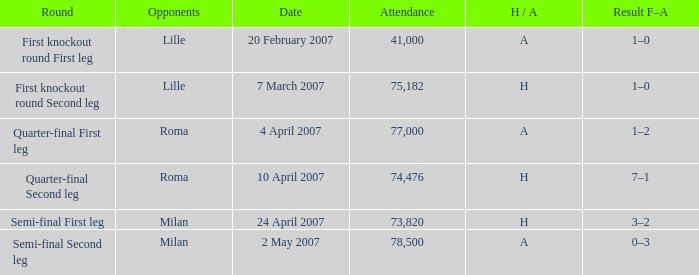Which round has Attendance larger than 41,000, a H/A of A, and a Result F–A of 1–2? Quarter-final First leg. 